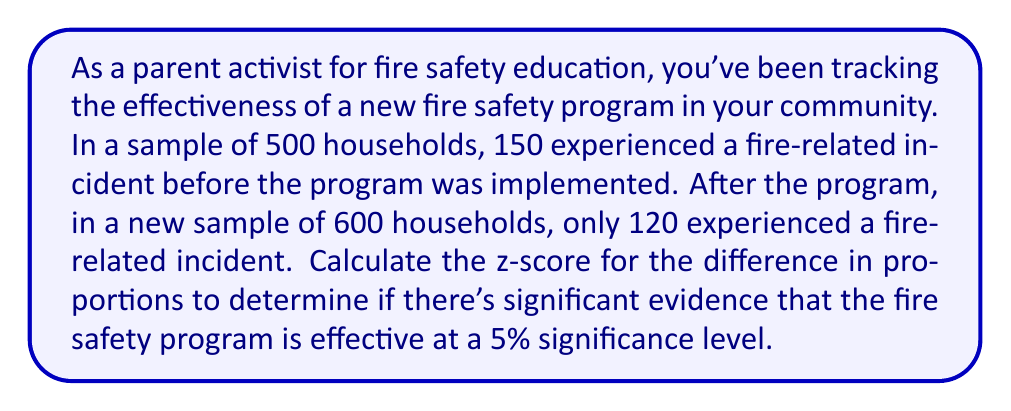Show me your answer to this math problem. To solve this problem, we'll use the z-test for the difference between two population proportions. Here are the steps:

1. Define the hypotheses:
   $H_0: p_1 - p_2 = 0$ (null hypothesis)
   $H_a: p_1 - p_2 > 0$ (alternative hypothesis, one-tailed test)

   Where $p_1$ is the proportion before the program and $p_2$ is the proportion after.

2. Calculate the sample proportions:
   $\hat{p}_1 = \frac{150}{500} = 0.3$
   $\hat{p}_2 = \frac{120}{600} = 0.2$

3. Calculate the pooled proportion:
   $$\hat{p} = \frac{n_1\hat{p}_1 + n_2\hat{p}_2}{n_1 + n_2} = \frac{500(0.3) + 600(0.2)}{500 + 600} = \frac{270}{1100} \approx 0.2455$$

4. Calculate the standard error of the difference:
   $$SE = \sqrt{\hat{p}(1-\hat{p})(\frac{1}{n_1} + \frac{1}{n_2})} = \sqrt{0.2455(1-0.2455)(\frac{1}{500} + \frac{1}{600})} \approx 0.0268$$

5. Calculate the z-score:
   $$z = \frac{(\hat{p}_1 - \hat{p}_2) - 0}{SE} = \frac{0.3 - 0.2}{0.0268} \approx 3.73$$

6. Determine the critical value:
   For a one-tailed test at 5% significance level, the critical z-value is 1.645.

7. Compare the calculated z-score to the critical value:
   3.73 > 1.645, so we reject the null hypothesis.
Answer: The z-score is approximately 3.73, which is greater than the critical value of 1.645. Therefore, we reject the null hypothesis at the 5% significance level. This provides strong evidence that the fire safety education program is effective in reducing fire-related incidents. 